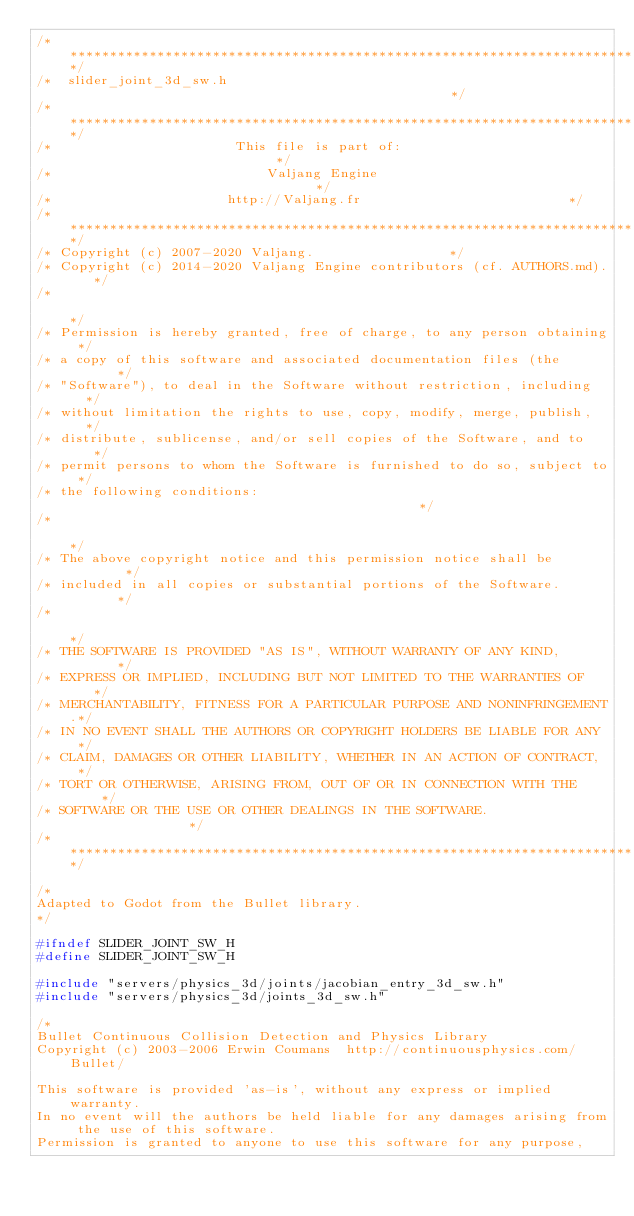Convert code to text. <code><loc_0><loc_0><loc_500><loc_500><_C_>/*************************************************************************/
/*  slider_joint_3d_sw.h                                                 */
/*************************************************************************/
/*                       This file is part of:                           */
/*                           Valjang Engine                                */
/*                      http://Valjang.fr                          */
/*************************************************************************/
/* Copyright (c) 2007-2020 Valjang.                 */
/* Copyright (c) 2014-2020 Valjang Engine contributors (cf. AUTHORS.md).   */
/*                                                                       */
/* Permission is hereby granted, free of charge, to any person obtaining */
/* a copy of this software and associated documentation files (the       */
/* "Software"), to deal in the Software without restriction, including   */
/* without limitation the rights to use, copy, modify, merge, publish,   */
/* distribute, sublicense, and/or sell copies of the Software, and to    */
/* permit persons to whom the Software is furnished to do so, subject to */
/* the following conditions:                                             */
/*                                                                       */
/* The above copyright notice and this permission notice shall be        */
/* included in all copies or substantial portions of the Software.       */
/*                                                                       */
/* THE SOFTWARE IS PROVIDED "AS IS", WITHOUT WARRANTY OF ANY KIND,       */
/* EXPRESS OR IMPLIED, INCLUDING BUT NOT LIMITED TO THE WARRANTIES OF    */
/* MERCHANTABILITY, FITNESS FOR A PARTICULAR PURPOSE AND NONINFRINGEMENT.*/
/* IN NO EVENT SHALL THE AUTHORS OR COPYRIGHT HOLDERS BE LIABLE FOR ANY  */
/* CLAIM, DAMAGES OR OTHER LIABILITY, WHETHER IN AN ACTION OF CONTRACT,  */
/* TORT OR OTHERWISE, ARISING FROM, OUT OF OR IN CONNECTION WITH THE     */
/* SOFTWARE OR THE USE OR OTHER DEALINGS IN THE SOFTWARE.                */
/*************************************************************************/

/*
Adapted to Godot from the Bullet library.
*/

#ifndef SLIDER_JOINT_SW_H
#define SLIDER_JOINT_SW_H

#include "servers/physics_3d/joints/jacobian_entry_3d_sw.h"
#include "servers/physics_3d/joints_3d_sw.h"

/*
Bullet Continuous Collision Detection and Physics Library
Copyright (c) 2003-2006 Erwin Coumans  http://continuousphysics.com/Bullet/

This software is provided 'as-is', without any express or implied warranty.
In no event will the authors be held liable for any damages arising from the use of this software.
Permission is granted to anyone to use this software for any purpose,</code> 